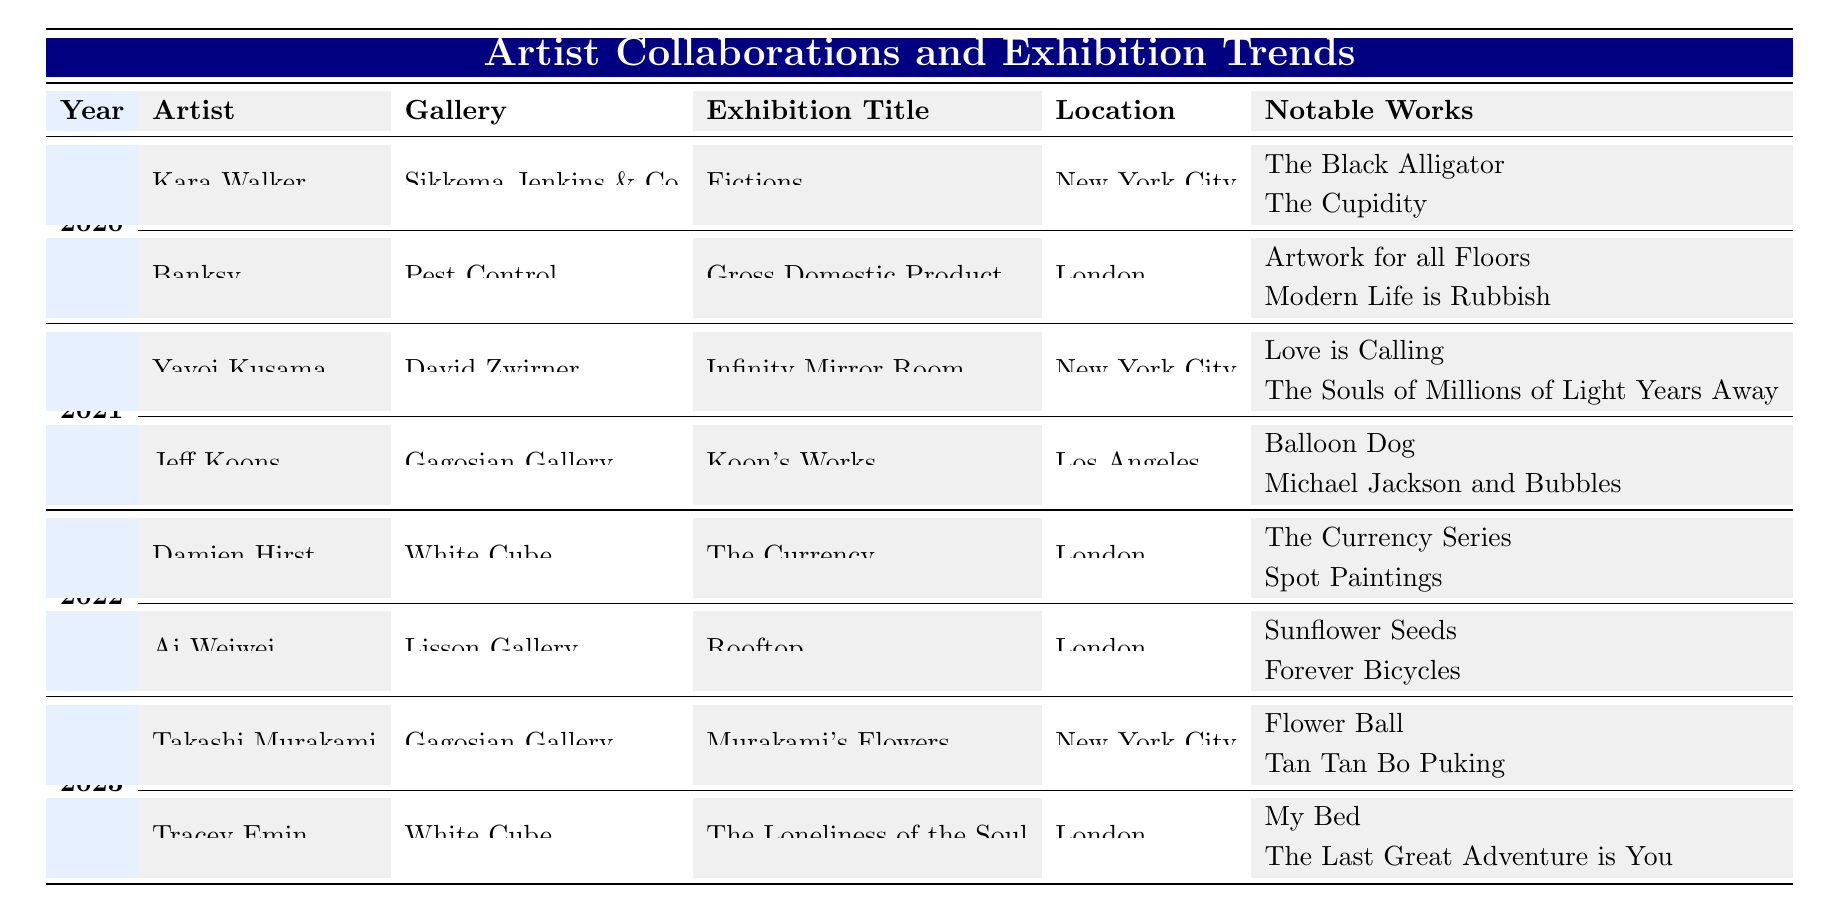What is the title of the exhibition by Kara Walker in 2020? The table shows the exhibition title for Kara Walker under the year 2020. Referring to the row that lists her collaboration, the exhibition title is "Fictions."
Answer: Fictions Which artist collaborated with Gagosian Gallery in 2021? Looking at the collaborations listed for the year 2021, the artist associated with Gagosian Gallery is Jeff Koons.
Answer: Jeff Koons How many exhibitions featured in 2022 were held in London? By examining the 2022 row, we can see that both exhibitions by Damien Hirst and Ai Weiwei listed in that year were held in London, totaling to 2 exhibitions.
Answer: 2 Is Yayoi Kusama's exhibition located in Los Angeles? The data indicates that Yayoi Kusama's exhibition in 2021 is located in New York City, not Los Angeles. Therefore, the answer is false.
Answer: False Which artist’s notable work includes "Flower Ball"? The table specifies that "Flower Ball" is a notable work of Takashi Murakami, who collaborated with Gagosian Gallery in the year 2023.
Answer: Takashi Murakami What is the average number of notable works per exhibition in 2023? In 2023, there are two exhibitions, each with two notable works (Murakami has "Flower Ball" and "Tan Tan Bo Puking," while Emin has "My Bed" and "The Last Great Adventure is You"). Thus, the average number of notable works per exhibition is (2 + 2) / 2 = 2.
Answer: 2 Which year had a collaboration with Sikkema Jenkins & Co? The table shows that Sikkema Jenkins & Co collaborated with Kara Walker in the year 2020.
Answer: 2020 What are the notable works by Ai Weiwei in 2022? The table lists Ai Weiwei's notable works under the year 2022 as "Sunflower Seeds" and "Forever Bicycles."
Answer: Sunflower Seeds, Forever Bicycles How many artists exhibited in 2020? From the data, there are two artists listed for the year 2020: Kara Walker and Banksy. Therefore, the total number of artists exhibiting that year is 2.
Answer: 2 